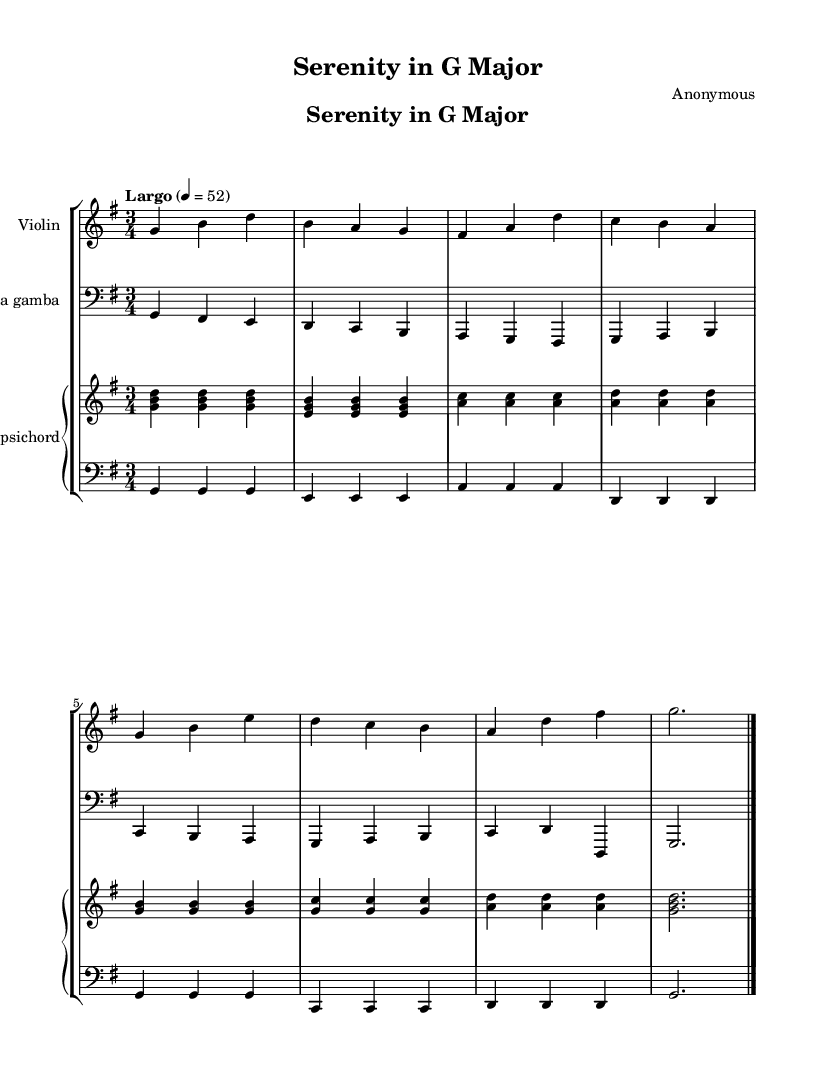What is the key signature of this music? The key signature is G major, which contains one sharp (F#). It can be identified by looking at the beginning of the staff where there are no flats and one sharp present on the F line.
Answer: G major What is the time signature of this piece? The time signature is 3/4, which indicates that there are three beats in each measure, and the quarter note gets the beat. This can be seen at the beginning of the sheet music.
Answer: 3/4 What is the tempo marking of this music? The tempo marking is Largo, which indicates a slow tempo. It is stated at the beginning of the score, designating the speed of the piece.
Answer: Largo How many measures are there in the piece? The piece has eight measures. This can be determined by counting the vertical bar lines that separate the measures in the score.
Answer: 8 Which instruments are featured in this composition? The instruments featured are Violin, Viola da gamba, and Harpsichord. The parts are labeled clearly above the staves, indicating what instruments play which section.
Answer: Violin, Viola da gamba, Harpsichord What is the texture of the music likely based on the instrument combination? The texture is likely polyphonic, as Baroque music often features multiple independent melodic lines that intertwine, which fits the combination of these instruments playing together. This reasoning is based on the characteristics of Baroque chamber music.
Answer: Polyphonic What is the overall mood suggested by the tempo and key signature? The overall mood is serene and calming, as the Largo tempo suggests a slow, meditative quality, and the key of G major is often associated with brightness and joy in Baroque music. Both elements contribute to a comforting atmosphere.
Answer: Serene and calming 